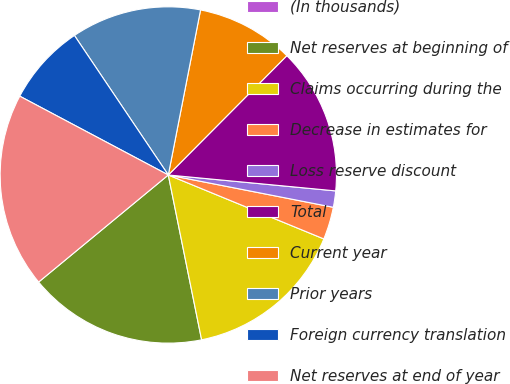<chart> <loc_0><loc_0><loc_500><loc_500><pie_chart><fcel>(In thousands)<fcel>Net reserves at beginning of<fcel>Claims occurring during the<fcel>Decrease in estimates for<fcel>Loss reserve discount<fcel>Total<fcel>Current year<fcel>Prior years<fcel>Foreign currency translation<fcel>Net reserves at end of year<nl><fcel>0.0%<fcel>17.19%<fcel>15.62%<fcel>3.13%<fcel>1.57%<fcel>14.06%<fcel>9.38%<fcel>12.5%<fcel>7.81%<fcel>18.75%<nl></chart> 